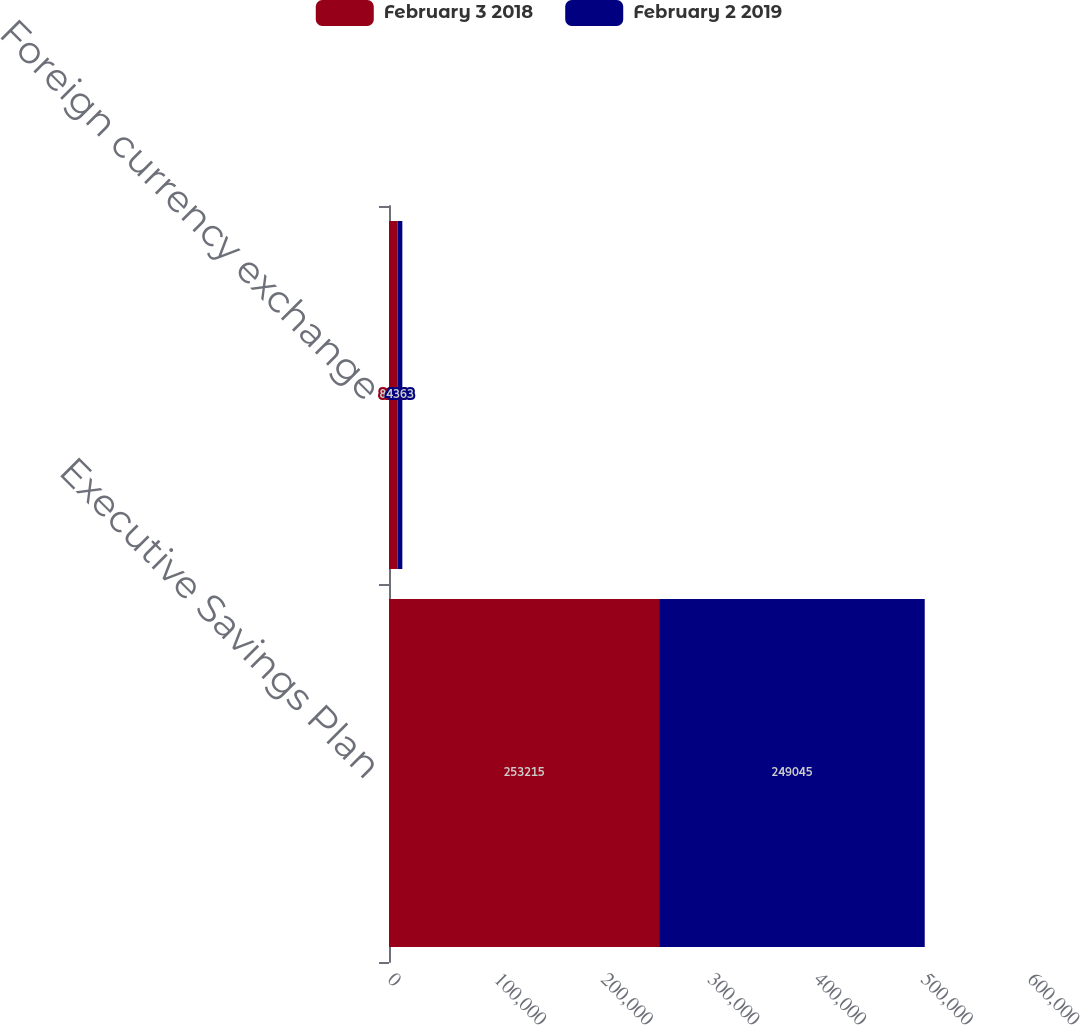Convert chart. <chart><loc_0><loc_0><loc_500><loc_500><stacked_bar_chart><ecel><fcel>Executive Savings Plan<fcel>Foreign currency exchange<nl><fcel>February 3 2018<fcel>253215<fcel>8136<nl><fcel>February 2 2019<fcel>249045<fcel>4363<nl></chart> 